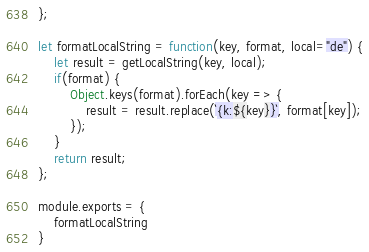Convert code to text. <code><loc_0><loc_0><loc_500><loc_500><_JavaScript_>};

let formatLocalString = function(key, format, local="de") {
    let result = getLocalString(key, local);
    if(format) {
        Object.keys(format).forEach(key => {
            result = result.replace(`{k:${key}}`, format[key]);
        });
    }
    return result;
};

module.exports = {
    formatLocalString
}</code> 